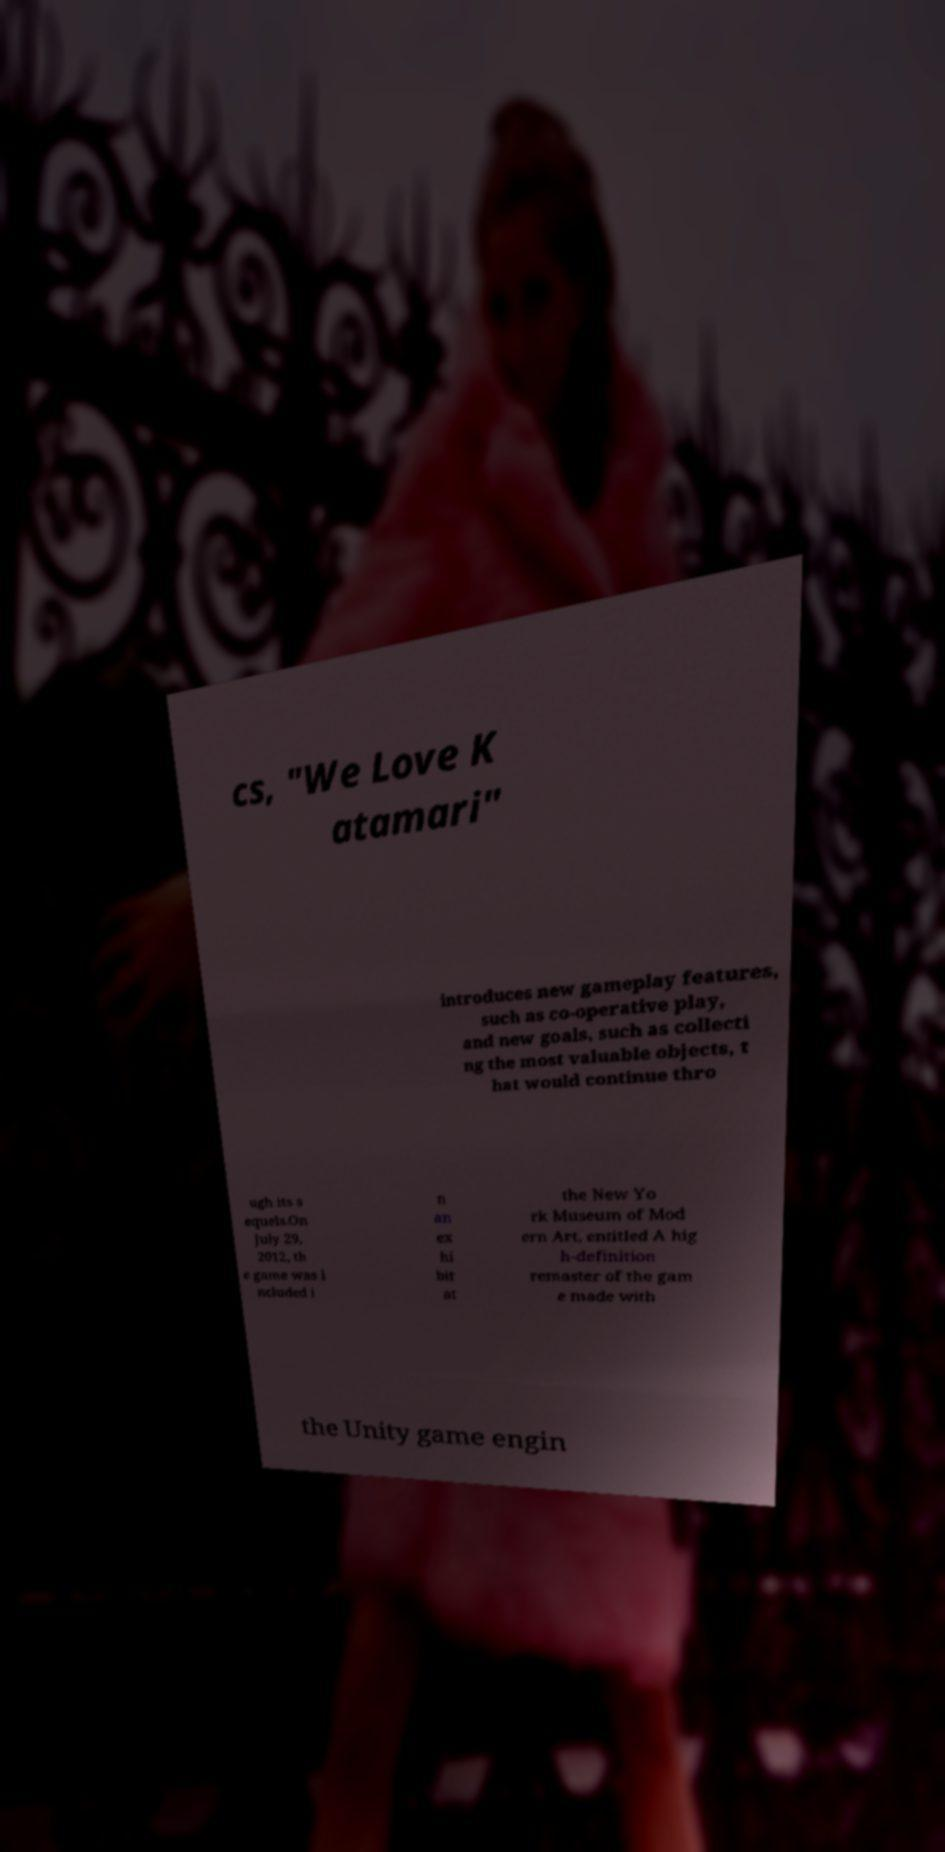Please read and relay the text visible in this image. What does it say? cs, "We Love K atamari" introduces new gameplay features, such as co-operative play, and new goals, such as collecti ng the most valuable objects, t hat would continue thro ugh its s equels.On July 29, 2012, th e game was i ncluded i n an ex hi bit at the New Yo rk Museum of Mod ern Art, entitled A hig h-definition remaster of the gam e made with the Unity game engin 